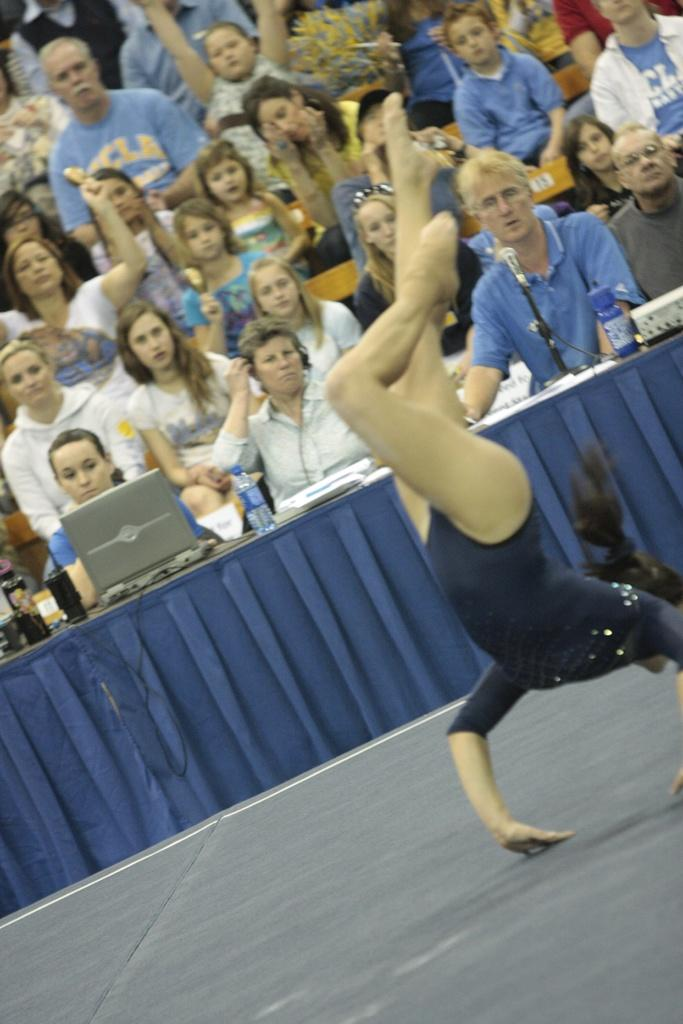What is the person in the foreground doing in the image? There is a person performing on the floor in the image. What objects can be seen in the background of the image? There is a table, a laptop, a bottle, a mic, and a group of persons in the background. What type of wool is being spun by the spiders in the image? There are no spiders or wool present in the image. What is the opinion of the group of persons in the background about the performance? The image does not provide any information about the opinions of the group of persons in the background. 